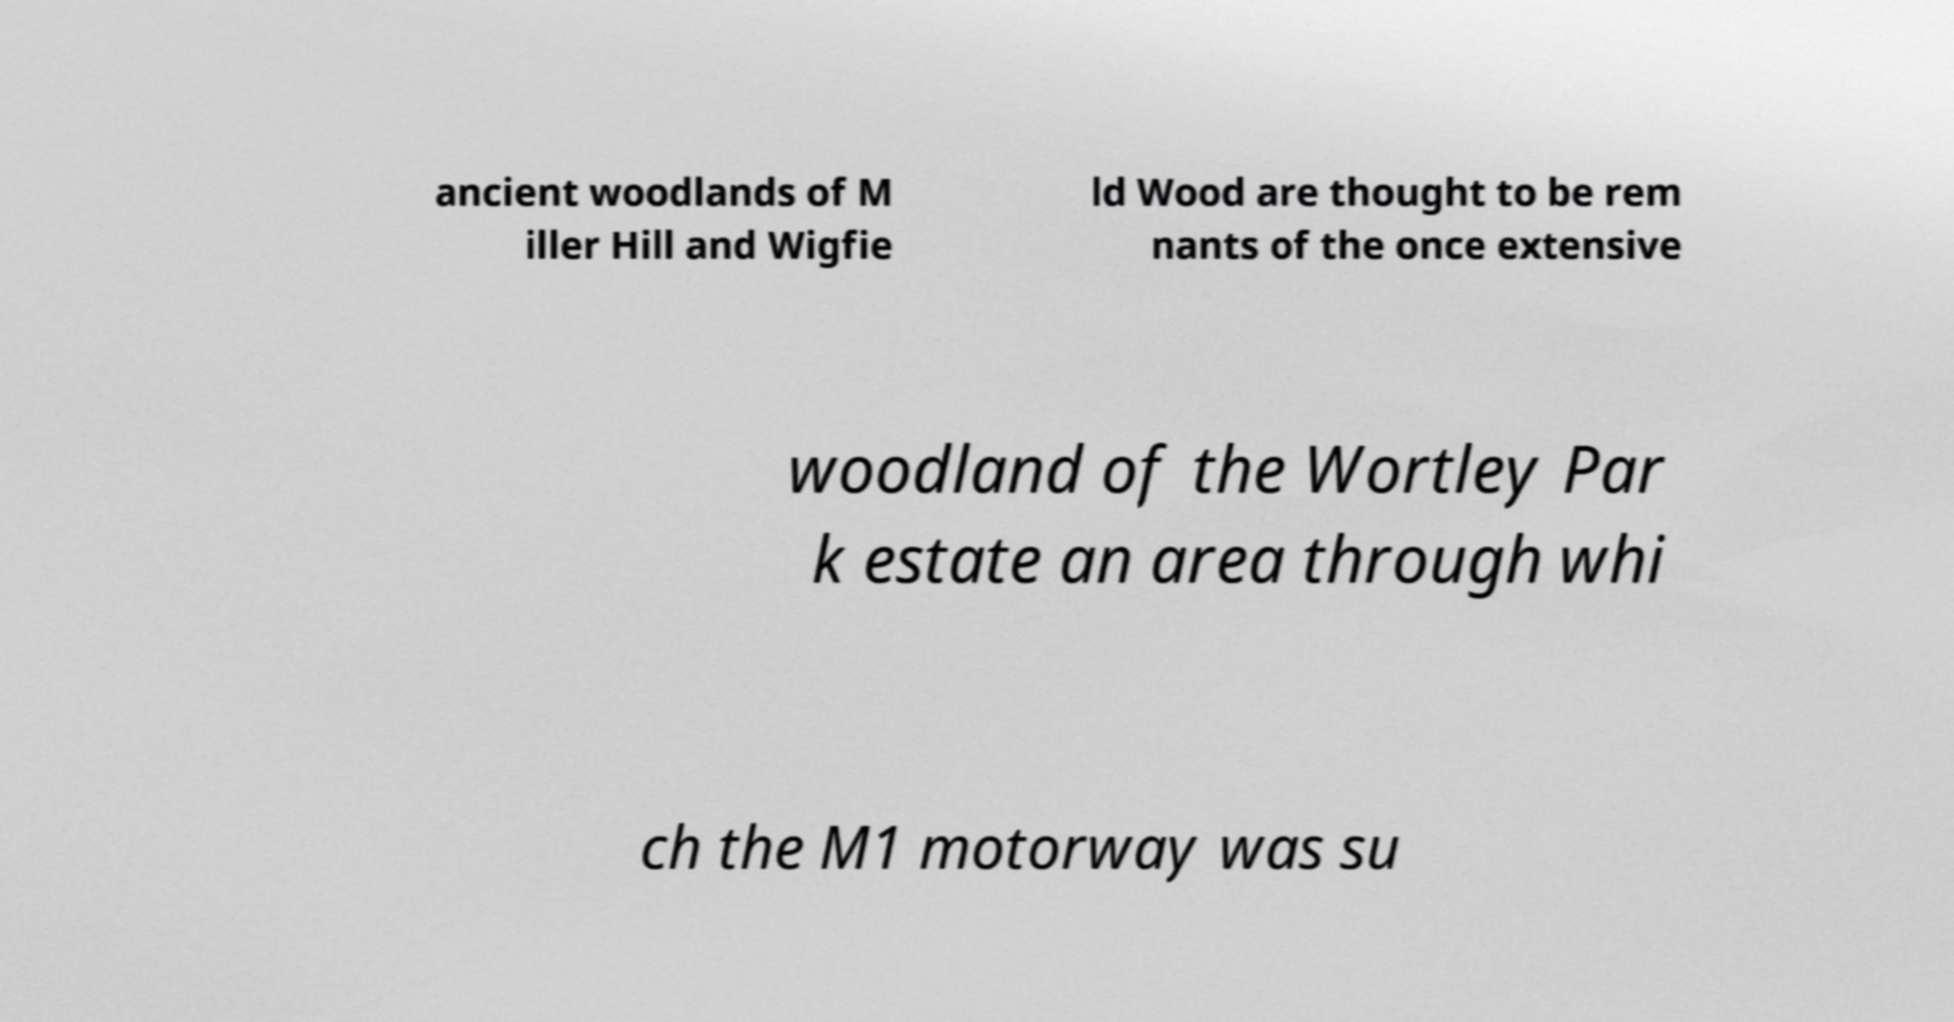There's text embedded in this image that I need extracted. Can you transcribe it verbatim? ancient woodlands of M iller Hill and Wigfie ld Wood are thought to be rem nants of the once extensive woodland of the Wortley Par k estate an area through whi ch the M1 motorway was su 